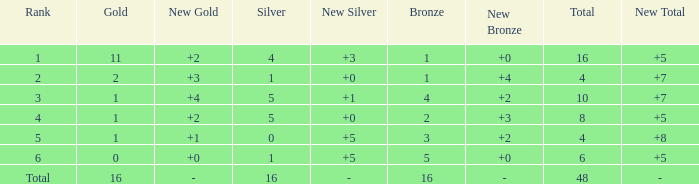How many gold are a rank 1 and larger than 16? 0.0. 